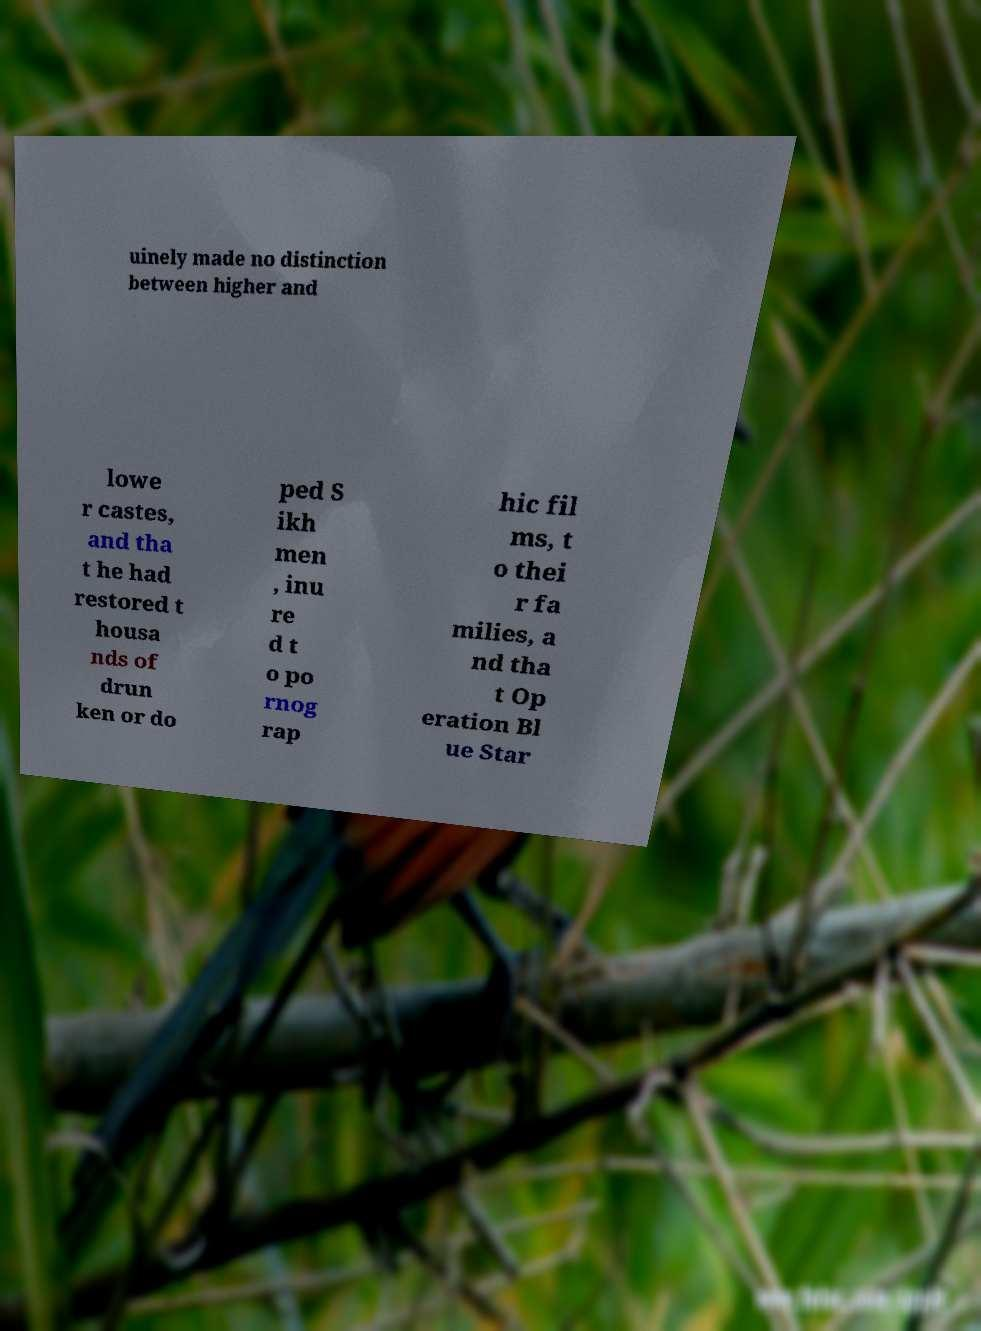Can you accurately transcribe the text from the provided image for me? uinely made no distinction between higher and lowe r castes, and tha t he had restored t housa nds of drun ken or do ped S ikh men , inu re d t o po rnog rap hic fil ms, t o thei r fa milies, a nd tha t Op eration Bl ue Star 